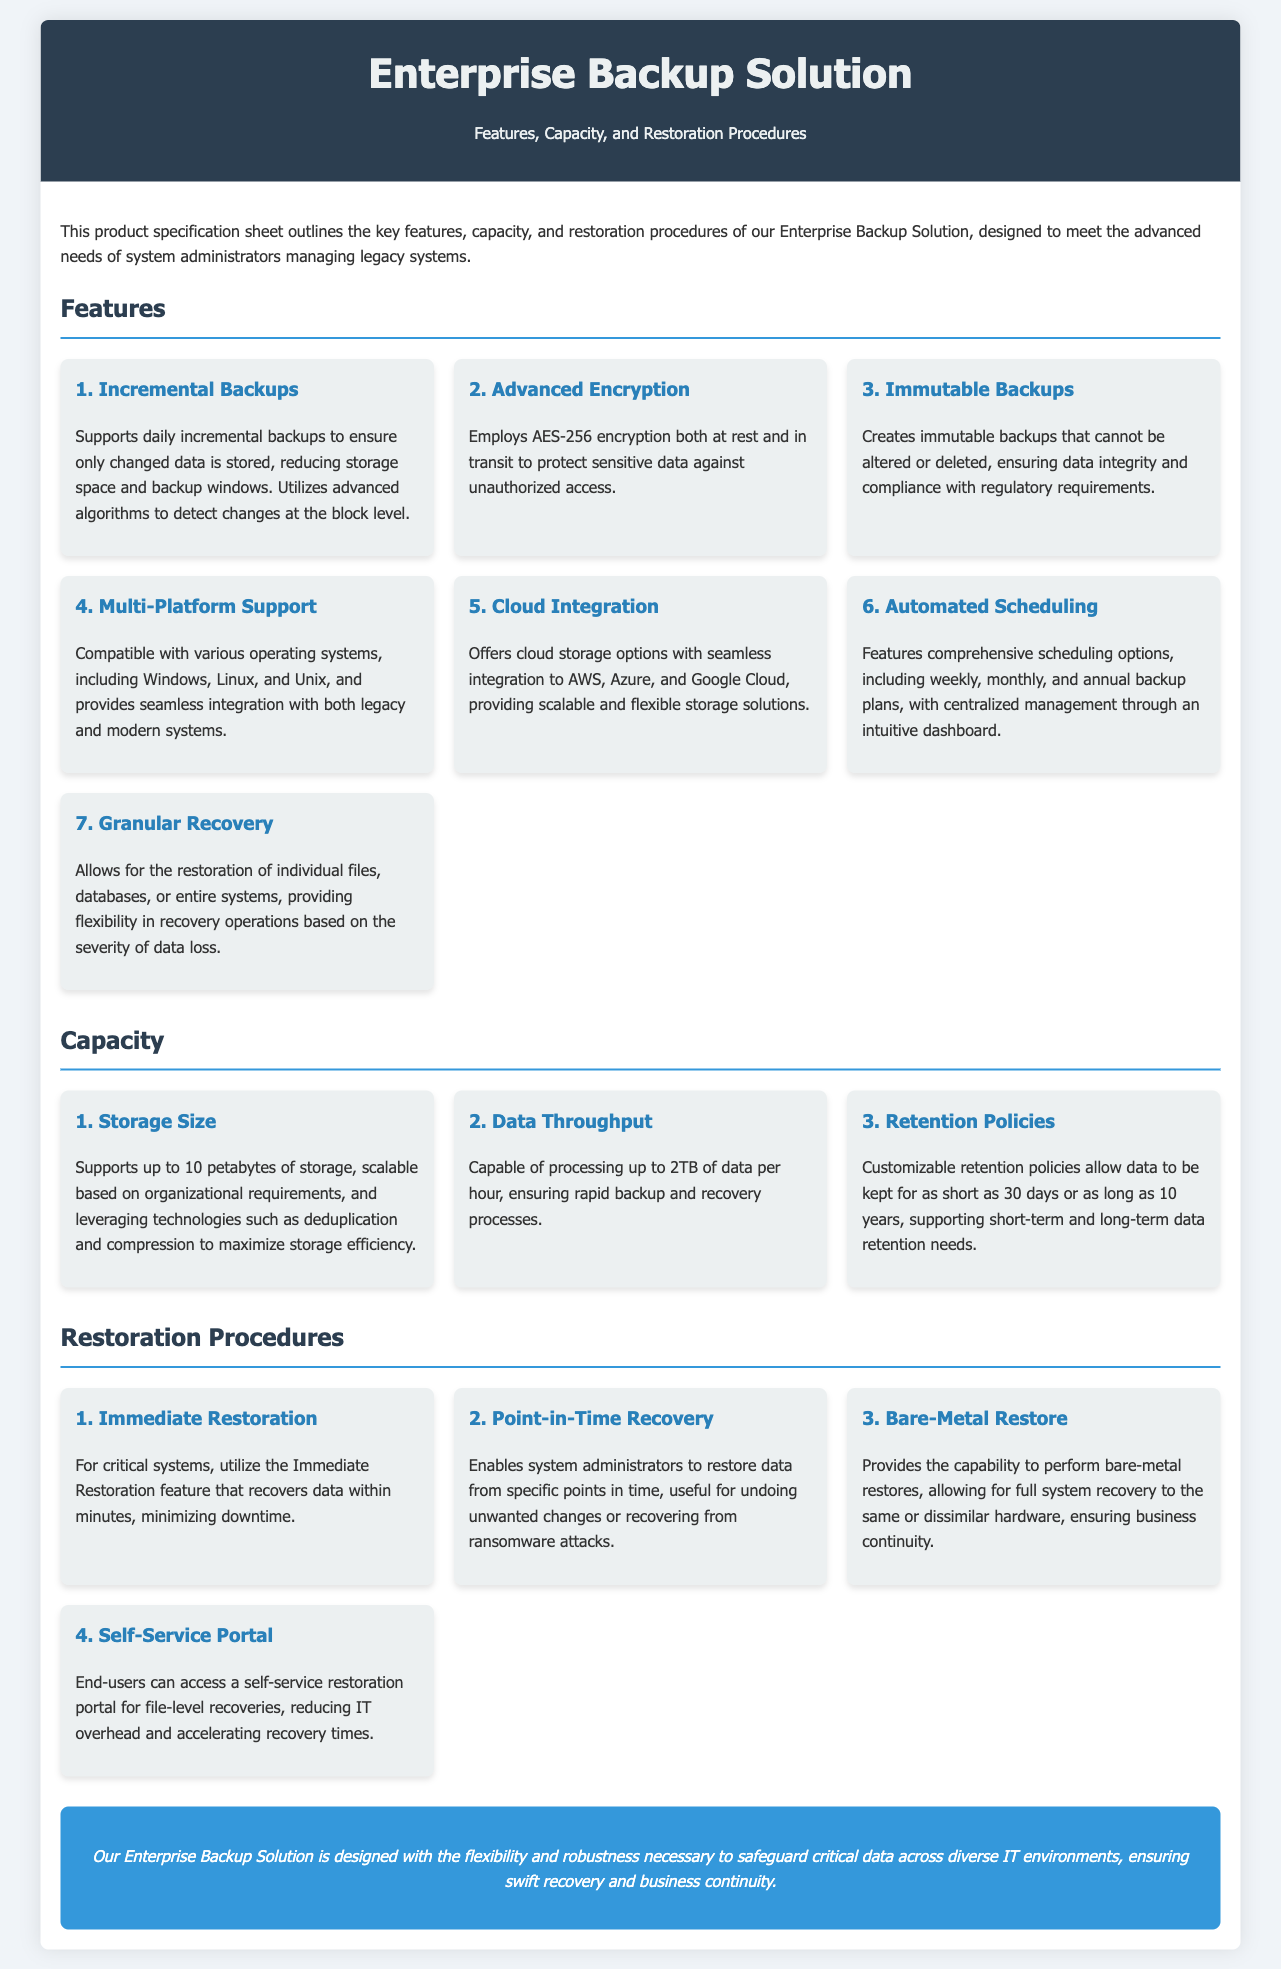What is the maximum storage size supported? The maximum storage size supported is mentioned as 10 petabytes in the Capacity section of the document.
Answer: 10 petabytes What encryption method is used? The document specifies that AES-256 encryption is employed at both rest and in transit.
Answer: AES-256 encryption How many types of backups are listed in the features? The Features section lists a total of seven distinct features related to the backup solution.
Answer: 7 What is the data throughput capability? According to the Capacity section, the solution can process up to 2TB of data per hour.
Answer: 2TB per hour What is the purpose of the self-service portal? The document states that the self-service portal allows end-users to perform file-level recoveries, reducing IT overhead.
Answer: File-level recoveries How long can data be retained according to the retention policies? The customizable retention policies mentioned in the Capacity section can retain data for a duration ranging from 30 days to 10 years.
Answer: 30 days to 10 years What feature allows for quick recovery of critical systems? The Immediate Restoration feature is noted to recover data within minutes for critical systems.
Answer: Immediate Restoration What does the bare-metal restore capability provide? The bare-metal restore feature allows for full system recovery to the same or dissimilar hardware, ensuring business continuity.
Answer: Full system recovery 